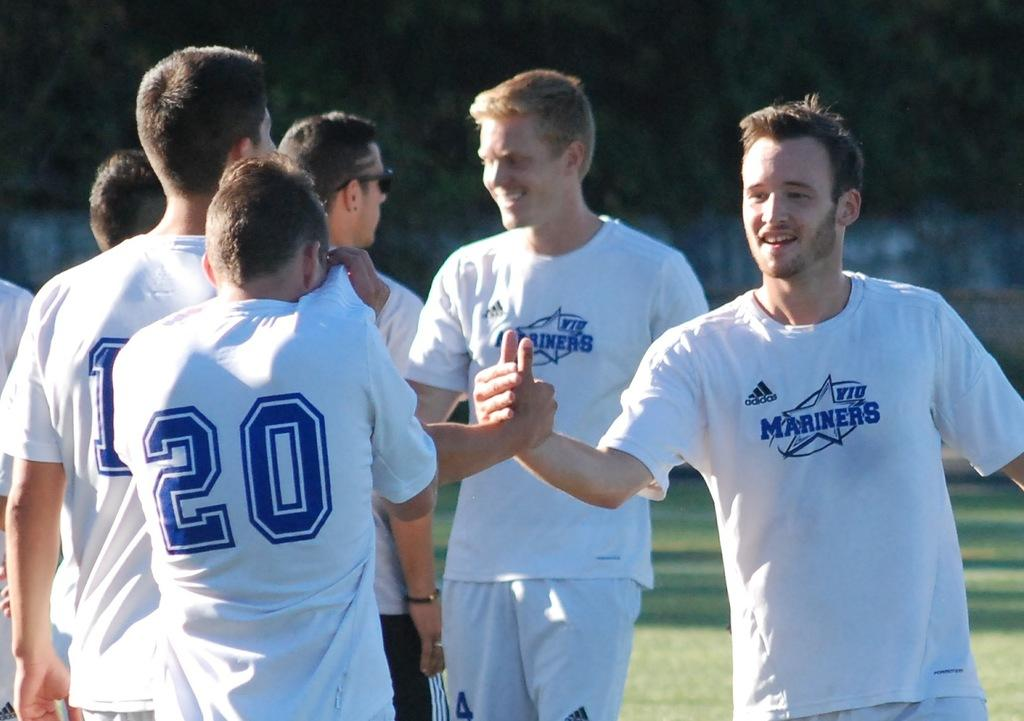<image>
Offer a succinct explanation of the picture presented. A group of men are shaking hands and wearing white shirts that say Mariners. 